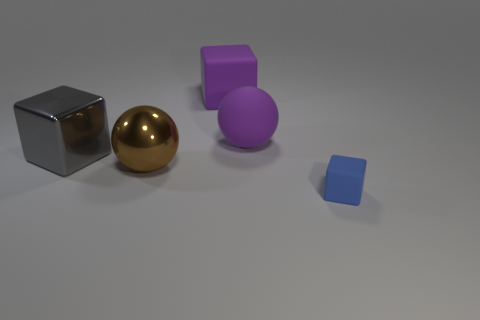What is the size of the matte block that is the same color as the matte ball?
Offer a terse response. Large. How many spheres are the same color as the large matte cube?
Give a very brief answer. 1. What is the material of the object that is the same color as the large rubber sphere?
Keep it short and to the point. Rubber. Does the purple rubber sphere have the same size as the purple rubber block?
Keep it short and to the point. Yes. There is a large metallic object on the left side of the brown sphere that is in front of the purple thing that is in front of the purple block; what is its shape?
Your answer should be very brief. Cube. The large rubber object that is the same shape as the tiny thing is what color?
Offer a terse response. Purple. There is a cube that is both in front of the big purple matte sphere and behind the large metal ball; what is its size?
Provide a succinct answer. Large. What number of matte cubes are in front of the large ball that is on the right side of the matte cube that is on the left side of the small blue object?
Provide a short and direct response. 1. How many small things are balls or yellow metallic things?
Offer a very short reply. 0. Are the big object behind the matte ball and the large gray thing made of the same material?
Your response must be concise. No. 